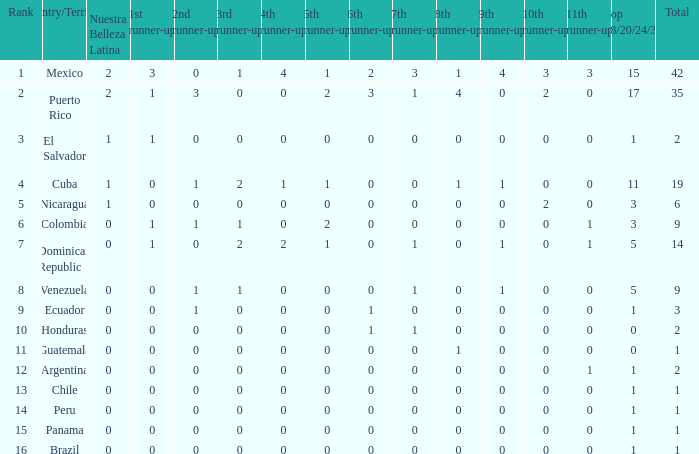What is the minimum 7th runner-up of the nation with a top 18/20/24/30 above 5, a 1st runner-up exceeding 0, and an 11th runner-up below 0? None. 